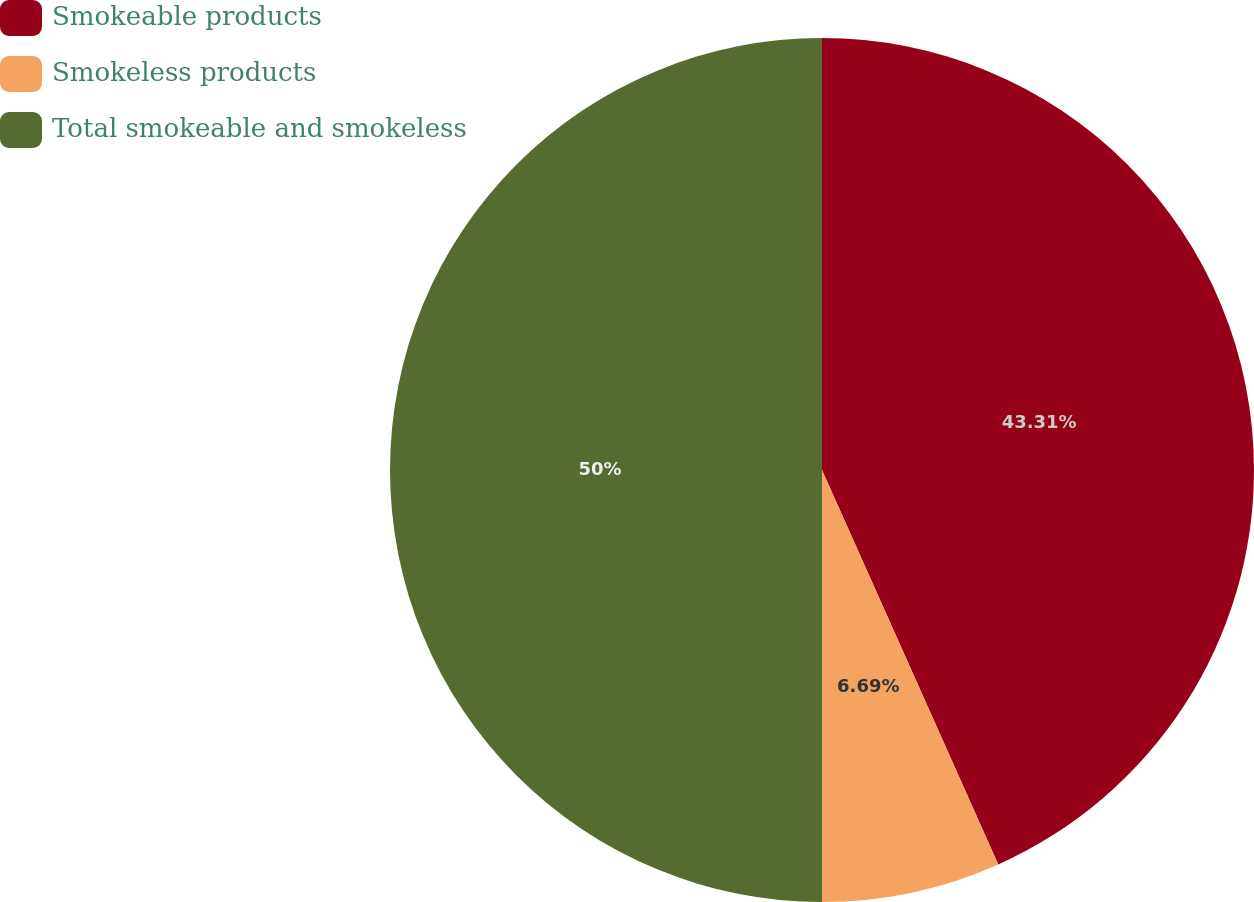Convert chart to OTSL. <chart><loc_0><loc_0><loc_500><loc_500><pie_chart><fcel>Smokeable products<fcel>Smokeless products<fcel>Total smokeable and smokeless<nl><fcel>43.31%<fcel>6.69%<fcel>50.0%<nl></chart> 